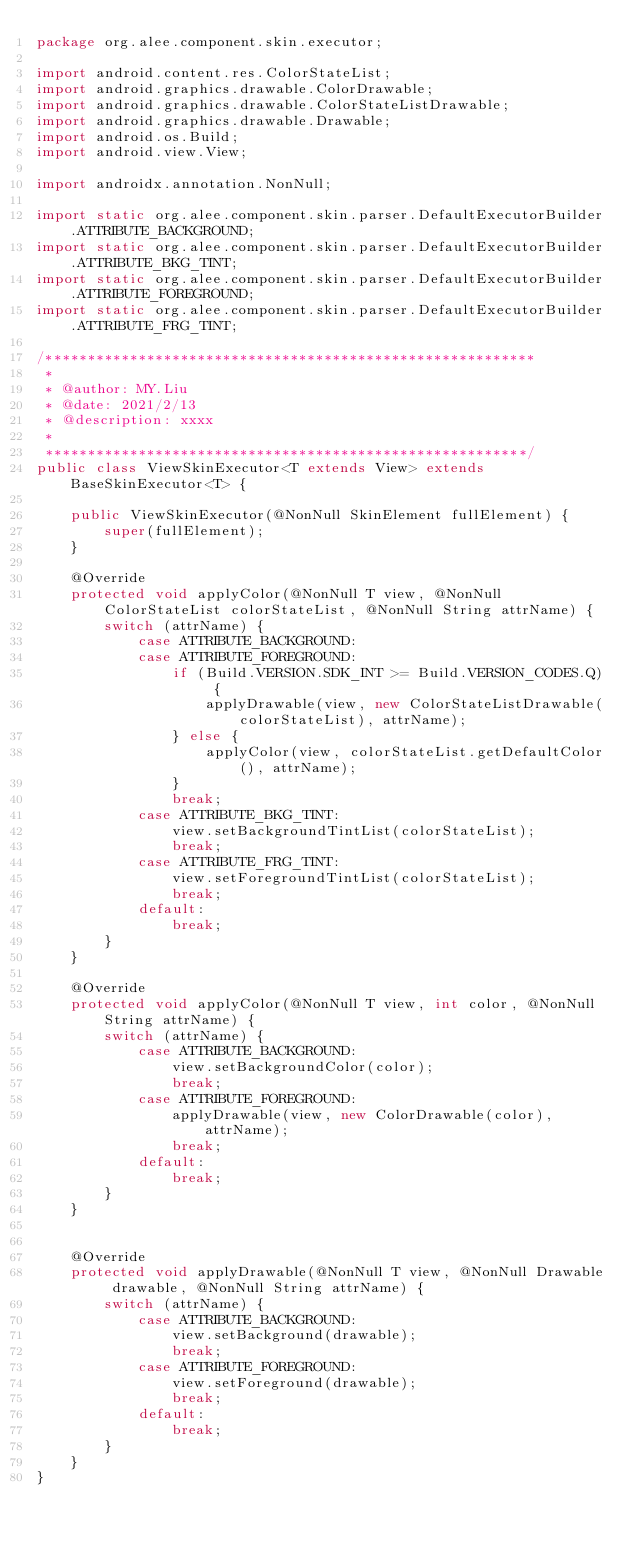<code> <loc_0><loc_0><loc_500><loc_500><_Java_>package org.alee.component.skin.executor;

import android.content.res.ColorStateList;
import android.graphics.drawable.ColorDrawable;
import android.graphics.drawable.ColorStateListDrawable;
import android.graphics.drawable.Drawable;
import android.os.Build;
import android.view.View;

import androidx.annotation.NonNull;

import static org.alee.component.skin.parser.DefaultExecutorBuilder.ATTRIBUTE_BACKGROUND;
import static org.alee.component.skin.parser.DefaultExecutorBuilder.ATTRIBUTE_BKG_TINT;
import static org.alee.component.skin.parser.DefaultExecutorBuilder.ATTRIBUTE_FOREGROUND;
import static org.alee.component.skin.parser.DefaultExecutorBuilder.ATTRIBUTE_FRG_TINT;

/**********************************************************
 *
 * @author: MY.Liu
 * @date: 2021/2/13
 * @description: xxxx
 *
 *********************************************************/
public class ViewSkinExecutor<T extends View> extends BaseSkinExecutor<T> {

    public ViewSkinExecutor(@NonNull SkinElement fullElement) {
        super(fullElement);
    }

    @Override
    protected void applyColor(@NonNull T view, @NonNull ColorStateList colorStateList, @NonNull String attrName) {
        switch (attrName) {
            case ATTRIBUTE_BACKGROUND:
            case ATTRIBUTE_FOREGROUND:
                if (Build.VERSION.SDK_INT >= Build.VERSION_CODES.Q) {
                    applyDrawable(view, new ColorStateListDrawable(colorStateList), attrName);
                } else {
                    applyColor(view, colorStateList.getDefaultColor(), attrName);
                }
                break;
            case ATTRIBUTE_BKG_TINT:
                view.setBackgroundTintList(colorStateList);
                break;
            case ATTRIBUTE_FRG_TINT:
                view.setForegroundTintList(colorStateList);
                break;
            default:
                break;
        }
    }

    @Override
    protected void applyColor(@NonNull T view, int color, @NonNull String attrName) {
        switch (attrName) {
            case ATTRIBUTE_BACKGROUND:
                view.setBackgroundColor(color);
                break;
            case ATTRIBUTE_FOREGROUND:
                applyDrawable(view, new ColorDrawable(color), attrName);
                break;
            default:
                break;
        }
    }


    @Override
    protected void applyDrawable(@NonNull T view, @NonNull Drawable drawable, @NonNull String attrName) {
        switch (attrName) {
            case ATTRIBUTE_BACKGROUND:
                view.setBackground(drawable);
                break;
            case ATTRIBUTE_FOREGROUND:
                view.setForeground(drawable);
                break;
            default:
                break;
        }
    }
}
</code> 